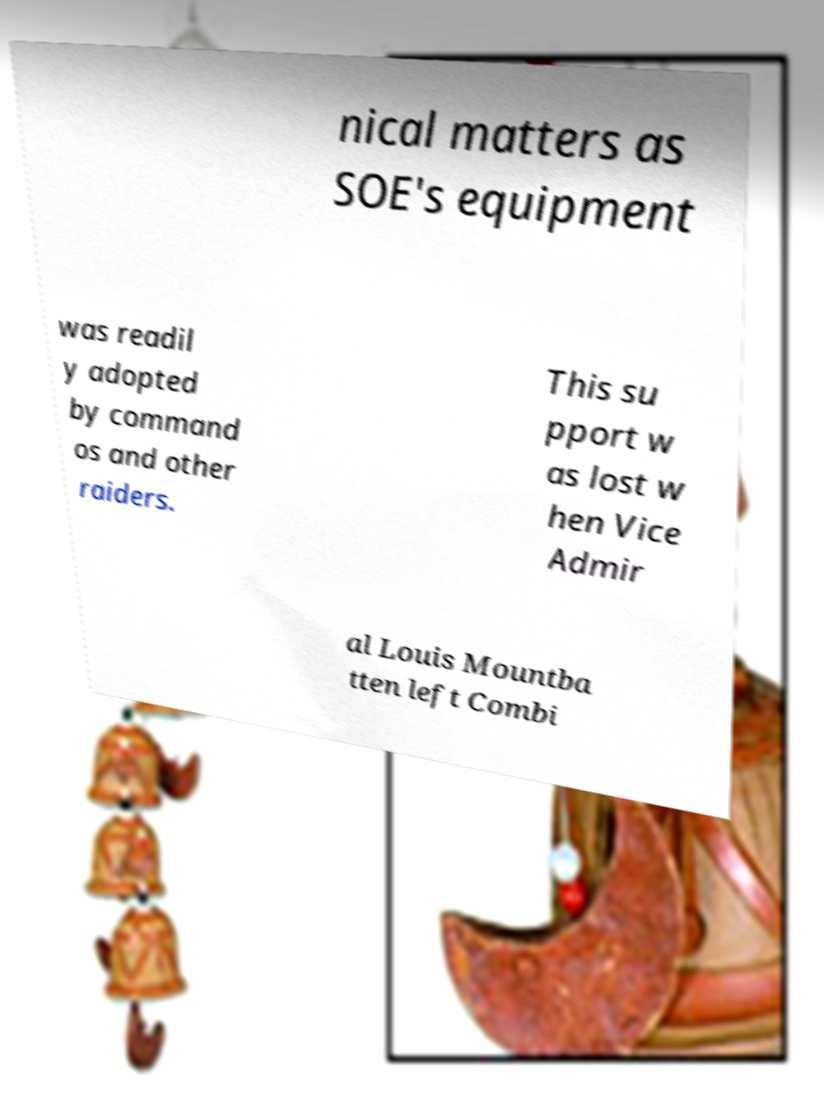Please identify and transcribe the text found in this image. nical matters as SOE's equipment was readil y adopted by command os and other raiders. This su pport w as lost w hen Vice Admir al Louis Mountba tten left Combi 